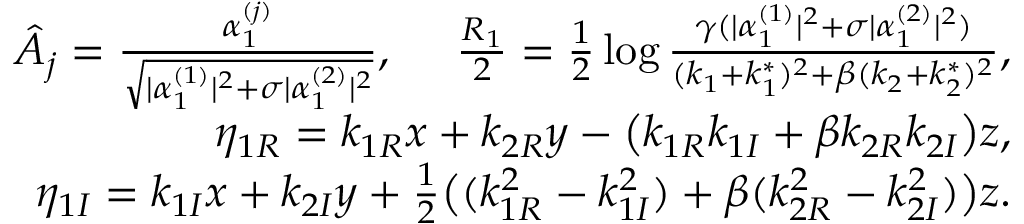<formula> <loc_0><loc_0><loc_500><loc_500>\begin{array} { r l r } & { \hat { A } _ { j } = \frac { \alpha _ { 1 } ^ { ( j ) } } { \sqrt { | \alpha _ { 1 } ^ { ( 1 ) } | ^ { 2 } + \sigma | \alpha _ { 1 } ^ { ( 2 ) } | ^ { 2 } } } , \frac { R _ { 1 } } { 2 } = \frac { 1 } { 2 } \log \frac { \gamma ( | \alpha _ { 1 } ^ { ( 1 ) } | ^ { 2 } + \sigma | \alpha _ { 1 } ^ { ( 2 ) } | ^ { 2 } ) } { ( k _ { 1 } + k _ { 1 } ^ { * } ) ^ { 2 } + \beta ( k _ { 2 } + k _ { 2 } ^ { * } ) ^ { 2 } } , } \\ & { \eta _ { 1 R } = k _ { 1 R } x + k _ { 2 R } y - \left ( k _ { 1 R } k _ { 1 I } + \beta k _ { 2 R } k _ { 2 I } \right ) z , } \\ & { \eta _ { 1 I } = k _ { 1 I } x + k _ { 2 I } y + \frac { 1 } { 2 } \left ( ( k _ { 1 R } ^ { 2 } - k _ { 1 I } ^ { 2 } ) + \beta ( k _ { 2 R } ^ { 2 } - k _ { 2 I } ^ { 2 } ) \right ) z . } \end{array}</formula> 